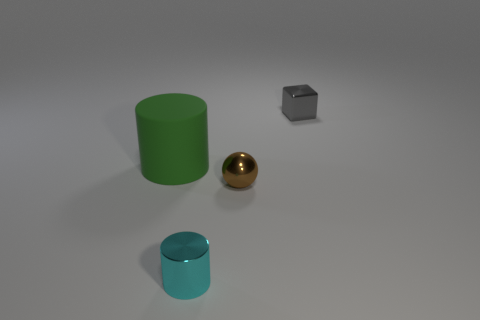Add 2 green matte cylinders. How many objects exist? 6 Subtract all spheres. How many objects are left? 3 Add 2 small gray matte cubes. How many small gray matte cubes exist? 2 Subtract 0 brown cylinders. How many objects are left? 4 Subtract all small cubes. Subtract all cyan things. How many objects are left? 2 Add 4 large green cylinders. How many large green cylinders are left? 5 